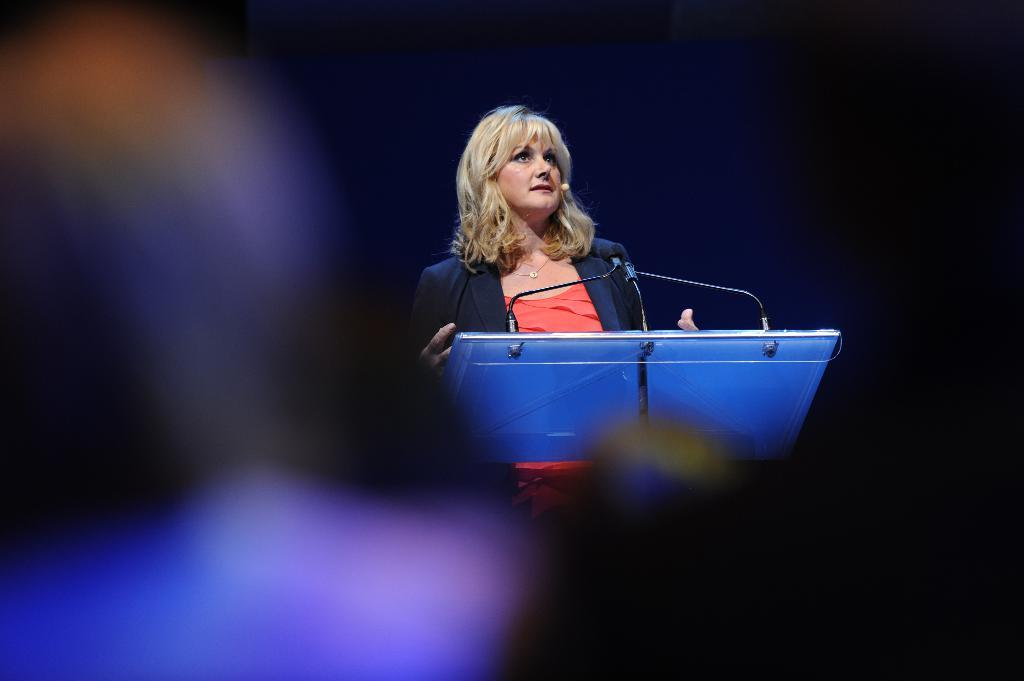What is the woman doing in the image? A woman is speaking in the microphone. What is the woman wearing on her upper body? The woman is wearing an orange t-shirt and a black coat. How many clovers can be seen in the image? There are no clovers present in the image. What type of money is the woman holding in the image? There is no money visible in the image; the woman is speaking into a microphone and wearing an orange t-shirt and a black coat. 